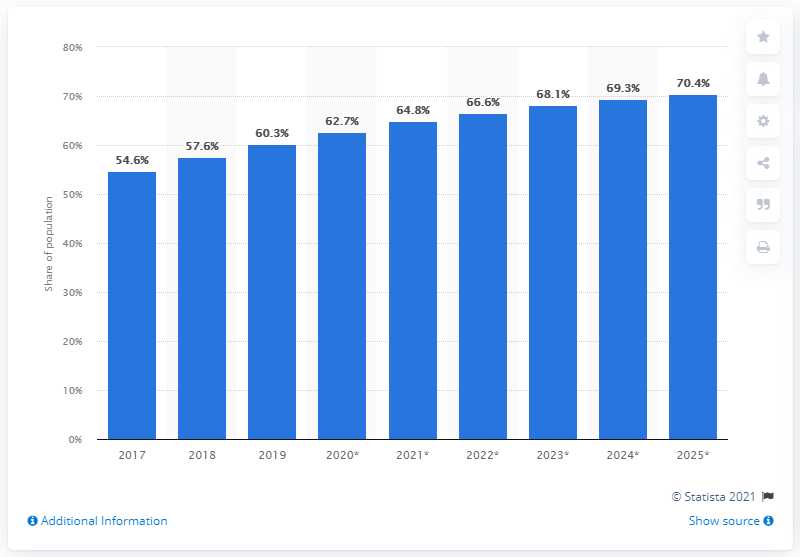Point out several critical features in this image. The projected share of Mexican social media in 2025 is expected to be 70.4%. 